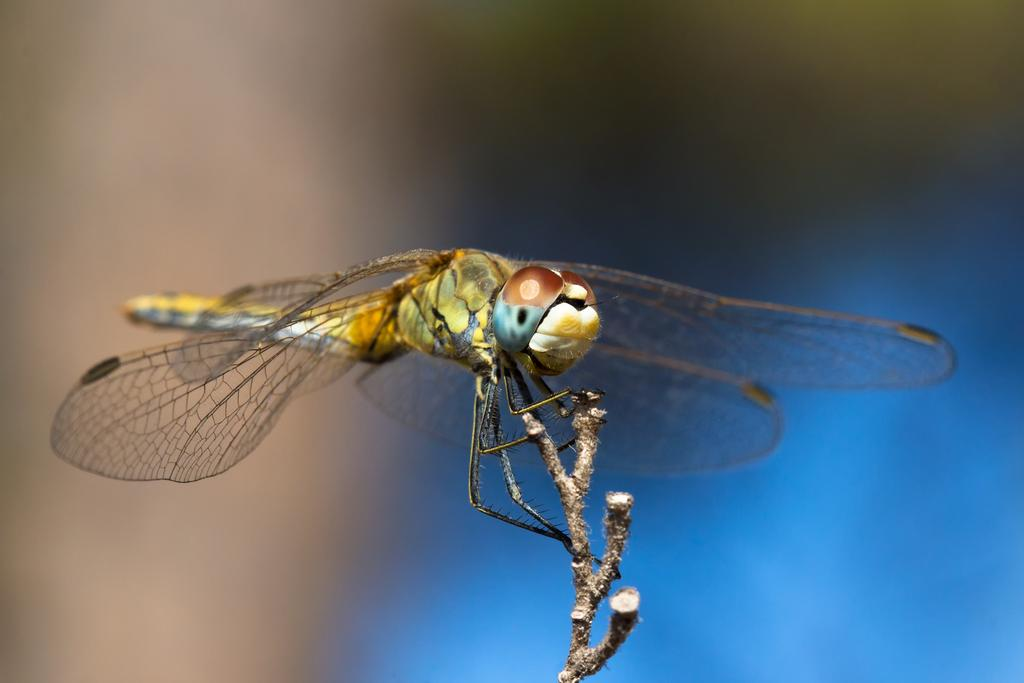What is present in the image? There is an insect in the image. Where is the insect located? The insect is on an object. Can you describe the background of the image? The background of the image is blurry. What type of oil is being used by the spy in the image? There is no spy or oil present in the image; it features an insect on an object with a blurry background. 